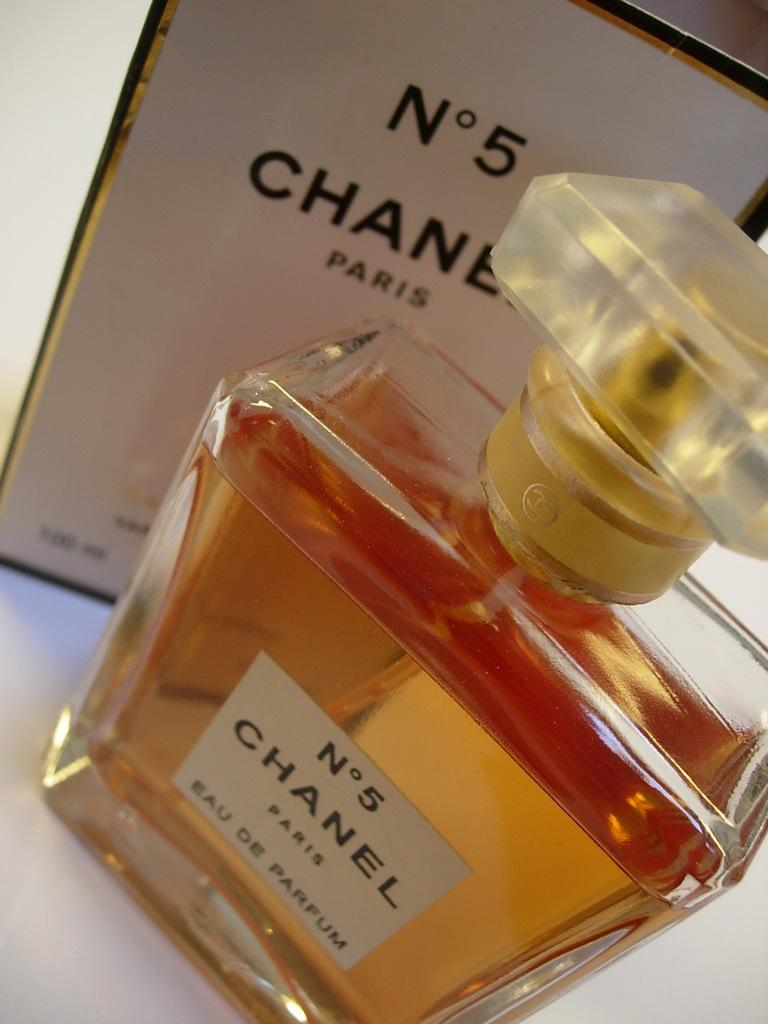<image>
Summarize the visual content of the image. a bottle of chanel number 5 with its box sitting next to it. 